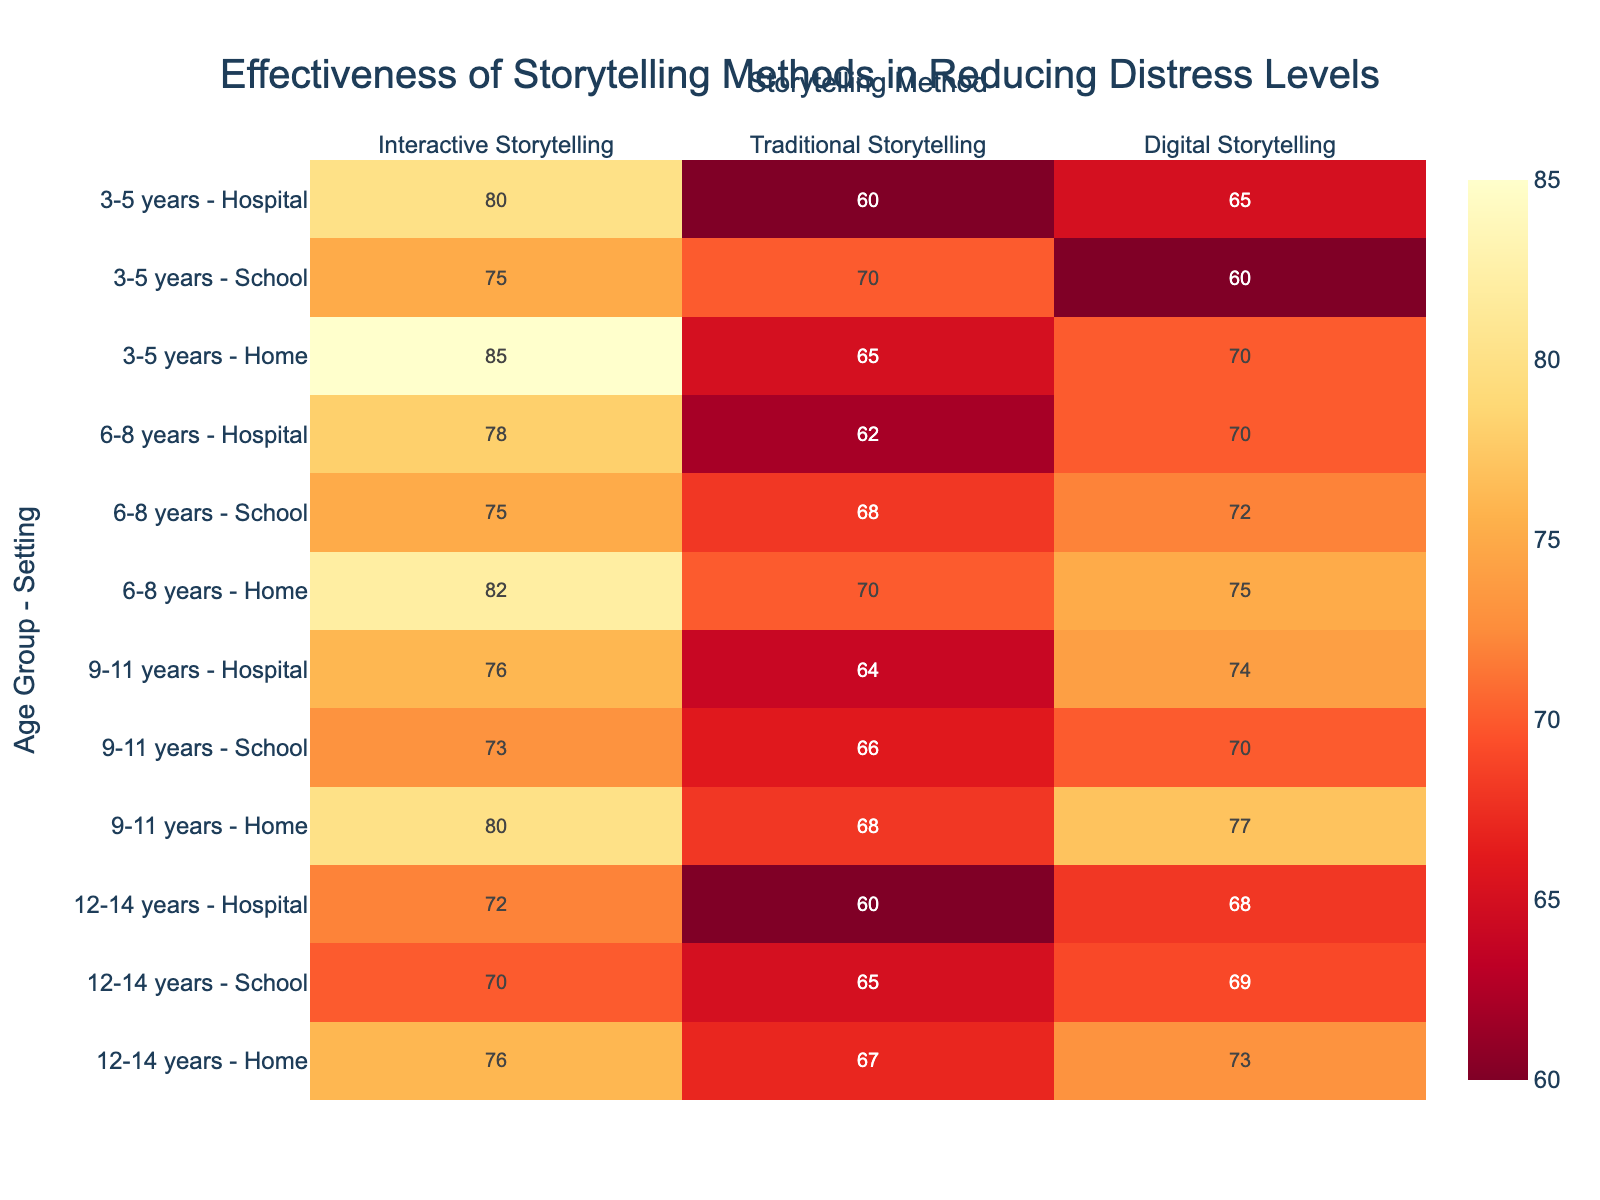What's the title of the heatmap? The title of the heatmap is stated at the top of the figure.
Answer: Effectiveness of Storytelling Methods in Reducing Distress Levels Which Storytelling Method shows the highest effectiveness for the 3-5 years age group in a Home setting? To find the answer, locate the 3-5 years Home row and compare the effectiveness values across the different storytelling methods.
Answer: Interactive Storytelling Which Age Group and Setting combination has the lowest effectiveness for Digital Storytelling? Examine all the rows under the Digital Storytelling column to determine the lowest value and its corresponding Age Group and Setting.
Answer: 3-5 years - School How does the effectiveness of Interactive Storytelling in Hospitals compare between the 6-8 years and 12-14 years age groups? Compare the effectiveness values for Interactive Storytelling in Hospital settings for the 6-8 and 12-14 years age groups.
Answer: Higher for 6-8 years (78 vs 72) What is the overall trend in effectiveness for Traditional Storytelling as children's age increases within School settings? Observe the effectiveness values for Traditional Storytelling across different age groups in School settings to determine if they increase or decrease.
Answer: Decreases What's the difference in effectiveness between Interactive and Traditional Storytelling for the 9-11 years age group in Home settings? Subtract the effectiveness value of Traditional Storytelling from that of Interactive Storytelling for the 9-11 years Home row.
Answer: 12 Which storytelling method is generally the most effective across all age groups and settings? Analyze the highest values in each row across all methods and see which method appears most frequently as the highest.
Answer: Interactive Storytelling How does the effectiveness of Digital Storytelling compare between Hospital and School settings for the 12-14 years age group? For the 12-14 years age group, compare the effectiveness values of Digital Storytelling in Hospital and School settings.
Answer: Higher in School (69 vs 68) What is the effectiveness range (difference between highest and lowest effectiveness) for Traditional Storytelling across all age groups in Home settings? Find the highest and lowest effectiveness values for Traditional Storytelling in Home settings and calculate the difference.
Answer: 3 (70 - 67) Which Age Group - Setting combination has the highest overall effectiveness for Interactive Storytelling? Search through the Interactive Storytelling column for the highest value and identify its corresponding Age Group and Setting.
Answer: 3-5 years - Home 